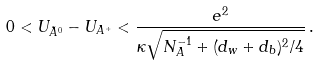Convert formula to latex. <formula><loc_0><loc_0><loc_500><loc_500>0 < U _ { \tilde { A } ^ { 0 } } - U _ { A ^ { + } } < \frac { e ^ { 2 } } { \kappa \sqrt { N _ { A } ^ { - 1 } + ( d _ { w } + d _ { b } ) ^ { 2 } / 4 } } \, .</formula> 